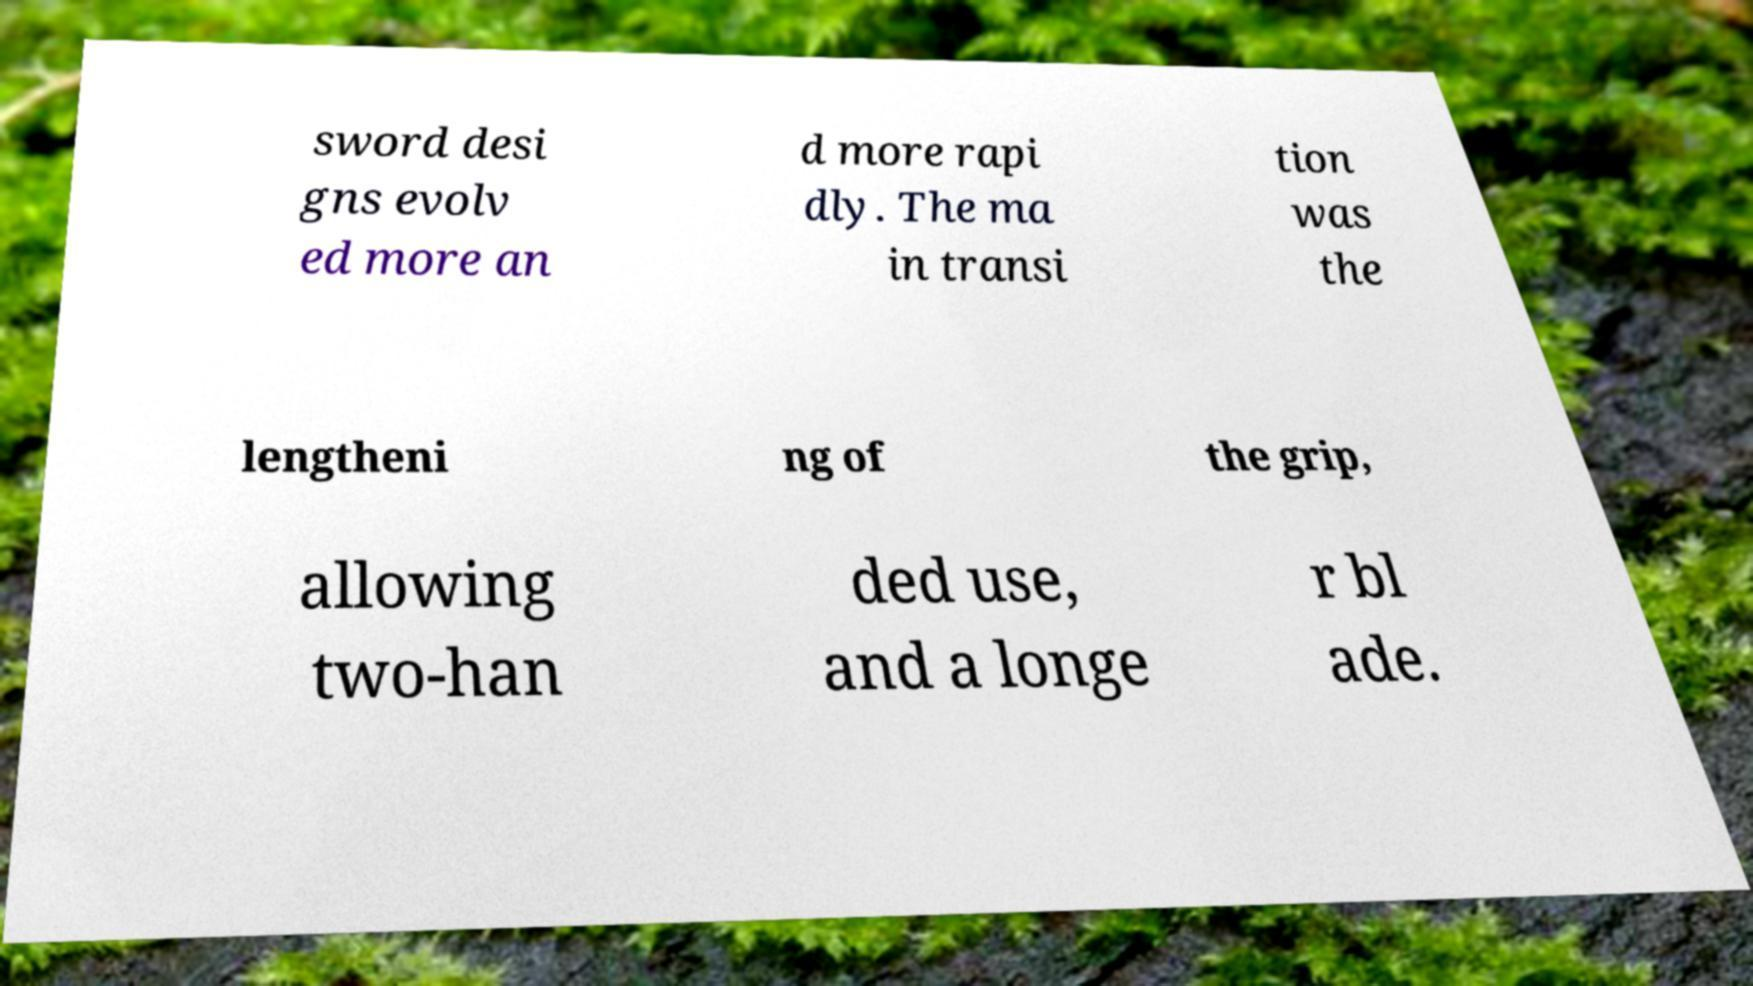I need the written content from this picture converted into text. Can you do that? sword desi gns evolv ed more an d more rapi dly. The ma in transi tion was the lengtheni ng of the grip, allowing two-han ded use, and a longe r bl ade. 